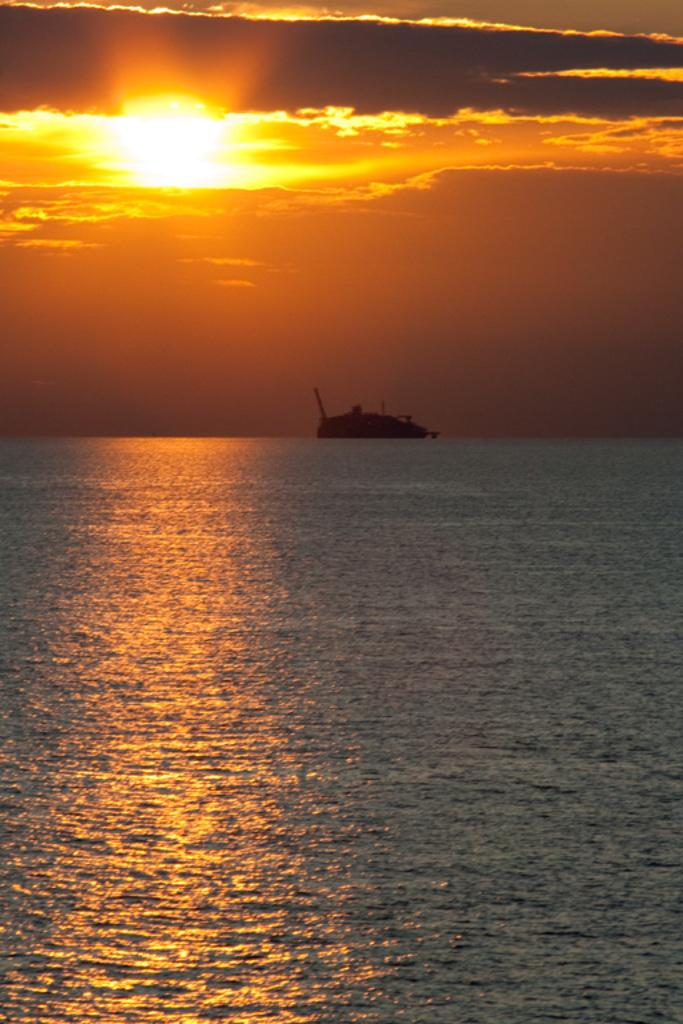What is visible in the image? Water is visible in the image. What can be seen in the background of the image? There is a sun and clouds in the background of the image. How many parent chickens are present in the image? There are no chickens or parents mentioned in the image; it only features water, a sun, and clouds. 